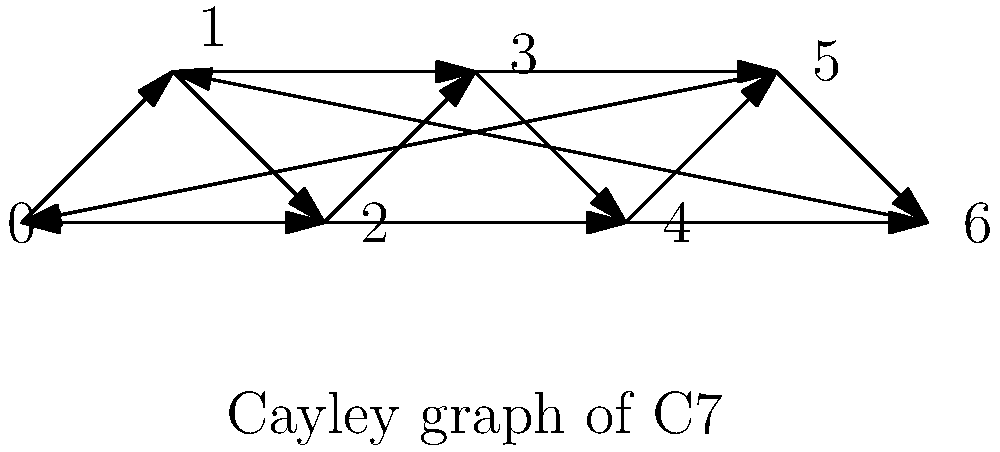As a singer-songwriter familiar with music theory, consider the Cayley graph of the diatonic scale group C7 shown above. If the generators of this group are {1, 2}, representing steps and skips in the scale, what is the total number of edges in this graph? To determine the total number of edges in the Cayley graph, we can follow these steps:

1) First, recall that in a Cayley graph, each vertex has an outgoing edge for each generator of the group.

2) In this case, we have two generators: 1 and 2.

3) The group C7 has 7 elements (represented by the vertices 0, 1, 2, 3, 4, 5, 6).

4) For each vertex:
   - There is one edge representing the generator 1 (step)
   - There is one edge representing the generator 2 (skip)

5) Therefore, each vertex has 2 outgoing edges.

6) Since there are 7 vertices, and each has 2 outgoing edges, the total number of edges is:

   $$7 \times 2 = 14$$

7) We can verify this by counting the edges in the graph: there are indeed 14 edges.

This graph structure is particularly relevant to music theory, as it represents the relationships between notes in a diatonic scale, with edges showing steps and skips between notes.
Answer: 14 